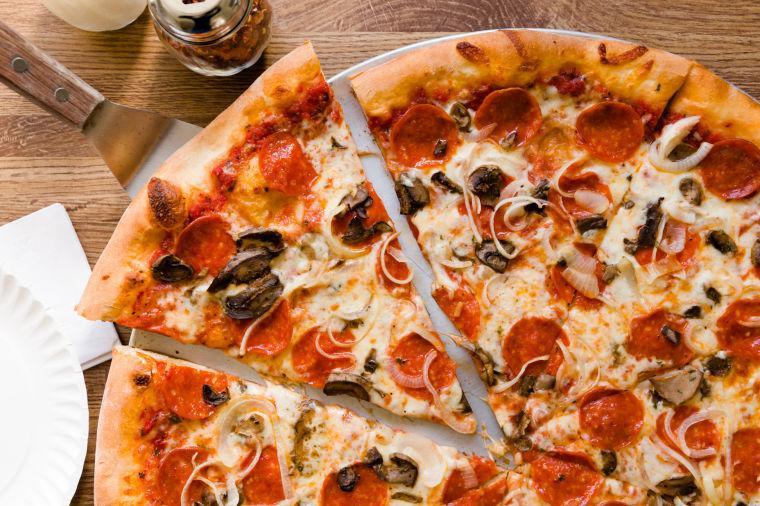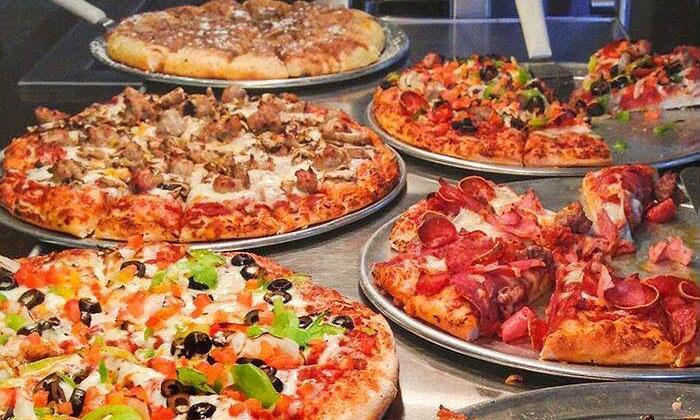The first image is the image on the left, the second image is the image on the right. For the images displayed, is the sentence "One image features a single round pizza that is not cut into slices, and the other image features one pepperoni pizza cut into wedge-shaped slices." factually correct? Answer yes or no. No. The first image is the image on the left, the second image is the image on the right. For the images shown, is this caption "One of the pizzas has onion on it." true? Answer yes or no. Yes. 